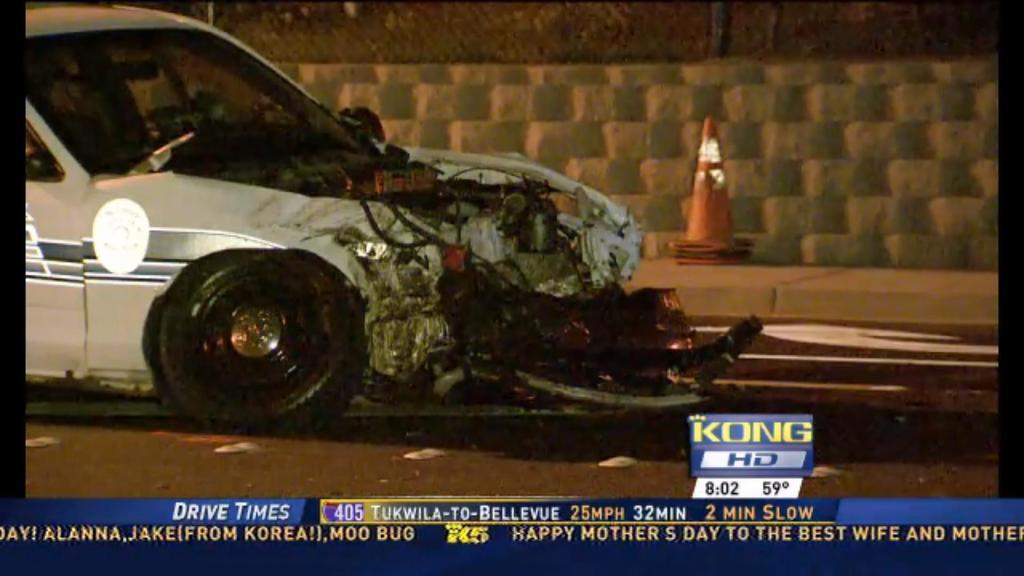Provide a one-sentence caption for the provided image. The TV is tuned to the channel KONG HD. 